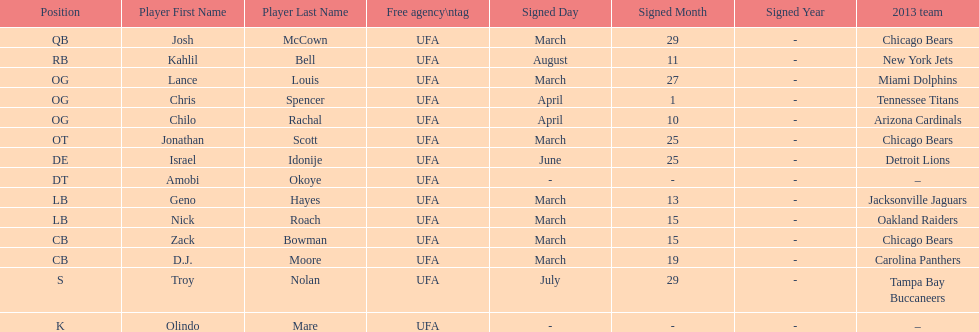What is the total of 2013 teams on the chart? 10. 